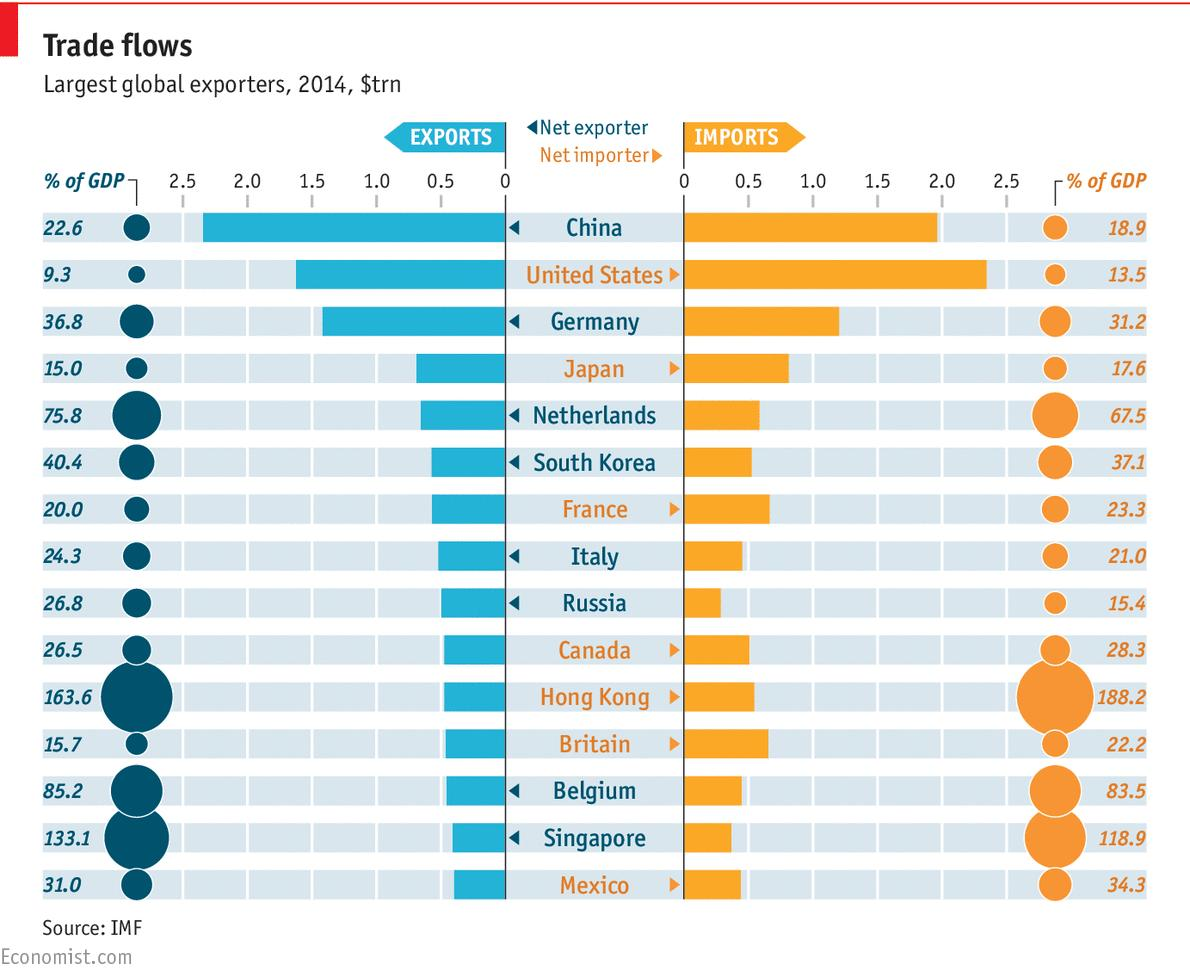Identify some key points in this picture. The color used to represent exports is blue. The color used to represent imports is orange. 